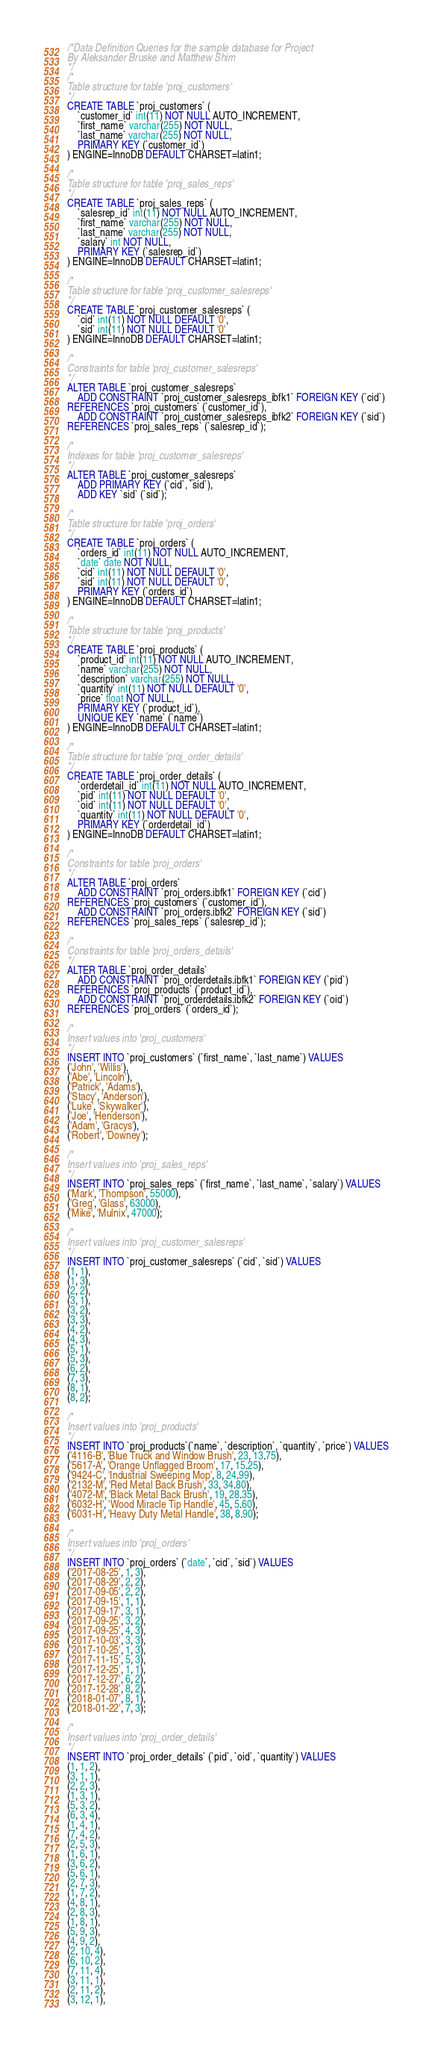<code> <loc_0><loc_0><loc_500><loc_500><_SQL_>/*Data Definition Queries for the sample database for Project
By Aleksander Bruske and Matthew Shim
*/
/*
Table structure for table 'proj_customers'
*/
CREATE TABLE `proj_customers` (
    `customer_id` int(11) NOT NULL AUTO_INCREMENT,
    `first_name` varchar(255) NOT NULL,
    `last_name` varchar(255) NOT NULL,
    PRIMARY KEY (`customer_id`)
) ENGINE=InnoDB DEFAULT CHARSET=latin1;

/*
Table structure for table 'proj_sales_reps'
*/
CREATE TABLE `proj_sales_reps` (
    `salesrep_id` int(11) NOT NULL AUTO_INCREMENT,
    `first_name` varchar(255) NOT NULL,
    `last_name` varchar(255) NOT NULL,
    `salary` int NOT NULL,
    PRIMARY KEY (`salesrep_id`)
) ENGINE=InnoDB DEFAULT CHARSET=latin1;

/*
Table structure for table 'proj_customer_salesreps'
*/
CREATE TABLE `proj_customer_salesreps` (
    `cid` int(11) NOT NULL DEFAULT '0',
    `sid` int(11) NOT NULL DEFAULT '0'
) ENGINE=InnoDB DEFAULT CHARSET=latin1;

/*
Constraints for table 'proj_customer_salesreps'
*/
ALTER TABLE `proj_customer_salesreps`
    ADD CONSTRAINT `proj_customer_salesreps_ibfk1` FOREIGN KEY (`cid`)
REFERENCES `proj_customers` (`customer_id`),
    ADD CONSTRAINT `proj_customer_salesreps_ibfk2` FOREIGN KEY (`sid`)
REFERENCES `proj_sales_reps` (`salesrep_id`);

/*
Indexes for table 'proj_customer_salesreps'
*/
ALTER TABLE `proj_customer_salesreps`
    ADD PRIMARY KEY (`cid`, `sid`),
    ADD KEY `sid` (`sid`);

/*
Table structure for table 'proj_orders'
*/
CREATE TABLE `proj_orders` (
    `orders_id` int(11) NOT NULL AUTO_INCREMENT,
    `date` date NOT NULL,
    `cid` int(11) NOT NULL DEFAULT '0',
    `sid` int(11) NOT NULL DEFAULT '0', 
    PRIMARY KEY (`orders_id`)
) ENGINE=InnoDB DEFAULT CHARSET=latin1;

/*
Table structure for table 'proj_products'
*/
CREATE TABLE `proj_products` (
    `product_id` int(11) NOT NULL AUTO_INCREMENT,
    `name` varchar(255) NOT NULL,
    `description` varchar(255) NOT NULL,
    `quantity` int(11) NOT NULL DEFAULT '0',
    `price` float NOT NULL,
    PRIMARY KEY (`product_id`),
    UNIQUE KEY `name` (`name`)
) ENGINE=InnoDB DEFAULT CHARSET=latin1;

/*
Table structure for table 'proj_order_details'
*/
CREATE TABLE `proj_order_details` (
    `orderdetail_id` int(11) NOT NULL AUTO_INCREMENT,
    `pid` int(11) NOT NULL DEFAULT '0',
    `oid` int(11) NOT NULL DEFAULT '0',
    `quantity` int(11) NOT NULL DEFAULT '0',
    PRIMARY KEY (`orderdetail_id`)
) ENGINE=InnoDB DEFAULT CHARSET=latin1;

/*
Constraints for table 'proj_orders'
*/
ALTER TABLE `proj_orders`
    ADD CONSTRAINT `proj_orders.ibfk1` FOREIGN KEY (`cid`)
REFERENCES `proj_customers` (`customer_id`),
    ADD CONSTRAINT `proj_orders.ibfk2` FOREIGN KEY (`sid`)
REFERENCES `proj_sales_reps` (`salesrep_id`);

/*
Constraints for table 'proj_orders_details'
*/
ALTER TABLE `proj_order_details`
    ADD CONSTRAINT `proj_orderdetails.ibfk1` FOREIGN KEY (`pid`)
REFERENCES `proj_products` (`product_id`),
    ADD CONSTRAINT `proj_orderdetails.ibfk2` FOREIGN KEY (`oid`)
REFERENCES `proj_orders` (`orders_id`);

/*
Insert values into 'proj_customers'
*/
INSERT INTO `proj_customers` (`first_name`, `last_name`) VALUES
('John', 'Willis'),
('Abe', 'Lincoln'),
('Patrick', 'Adams'),
('Stacy', 'Anderson'),
('Luke', 'Skywalker'),
('Joe', 'Henderson'),
('Adam', 'Gracys'),
('Robert', 'Downey');

/*
Insert values into 'proj_sales_reps'
*/
INSERT INTO `proj_sales_reps` (`first_name`, `last_name`, `salary`) VALUES
('Mark', 'Thompson', 55000),
('Greg', 'Glass', 63000),
('Mike', 'Mulnix', 47000);

/*
Insert values into 'proj_customer_salesreps'
*/
INSERT INTO `proj_customer_salesreps` (`cid`, `sid`) VALUES
(1, 1),
(1, 3),
(2, 2),
(3, 1),
(3, 2),
(3, 3),
(4, 2),
(4, 3),
(5, 1),
(5, 3),
(6, 2),
(7, 3),
(8, 1),
(8, 2);

/*
Insert values into 'proj_products'
*/
INSERT INTO `proj_products`(`name`, `description`, `quantity`, `price`) VALUES
('4116-B', 'Blue Truck and Window Brush', 23, 13.75),
('5617-A', 'Orange Unflagged Broom', 17, 15.25),
('9424-C', 'Industrial Sweeping Mop', 8, 24.99),
('2132-M', 'Red Metal Back Brush', 33, 34.80),
('4072-M', 'Black Metal Back Brush', 19, 28.35),
('6032-H', 'Wood Miracle Tip Handle', 45, 5.60),
('6031-H', 'Heavy Duty Metal Handle', 38, 8.90);

/*
Insert values into 'proj_orders'
*/
INSERT INTO `proj_orders` (`date`, `cid`, `sid`) VALUES
('2017-08-25', 1, 3),
('2017-08-29', 2, 2),
('2017-09-05', 2, 2),
('2017-09-15', 1, 1),
('2017-09-17', 3, 1),
('2017-09-25', 3, 2),
('2017-09-25', 4, 3),
('2017-10-03', 3, 3),
('2017-10-25', 1, 3),
('2017-11-15', 5, 3),
('2017-12-25', 1, 1),
('2017-12-27', 6, 2),
('2017-12-28', 8, 2),
('2018-01-07', 8, 1),
('2018-01-22', 7, 3);

/*
Insert values into 'proj_order_details'
*/
INSERT INTO `proj_order_details` (`pid`, `oid`, `quantity`) VALUES
(1, 1, 2),
(3, 1, 1),
(2, 2, 3),
(1, 3, 1),
(5, 3, 2),
(6, 3, 4),
(1, 4, 1),
(7, 4, 2),
(2, 5, 3),
(1, 6, 1),
(3, 6, 2),
(5, 6, 1),
(2, 7, 3),
(1, 7, 2),
(4, 8, 1),
(2, 8, 3),
(1, 8, 1),
(5, 9, 3),
(4, 9, 2),
(2, 10, 4),
(6, 10, 2),
(7, 11, 4),
(3, 11, 1),
(2, 11, 2),
(3, 12, 1),</code> 